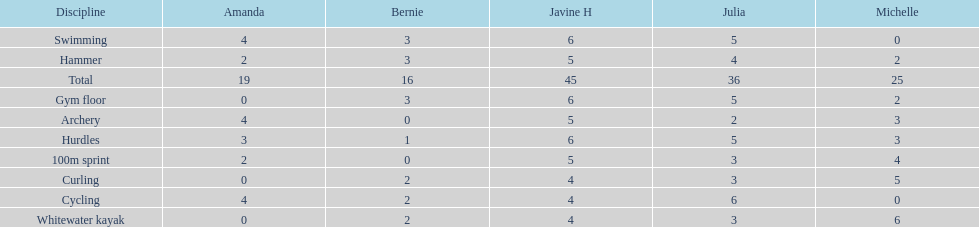Who earned the most total points? Javine H. 